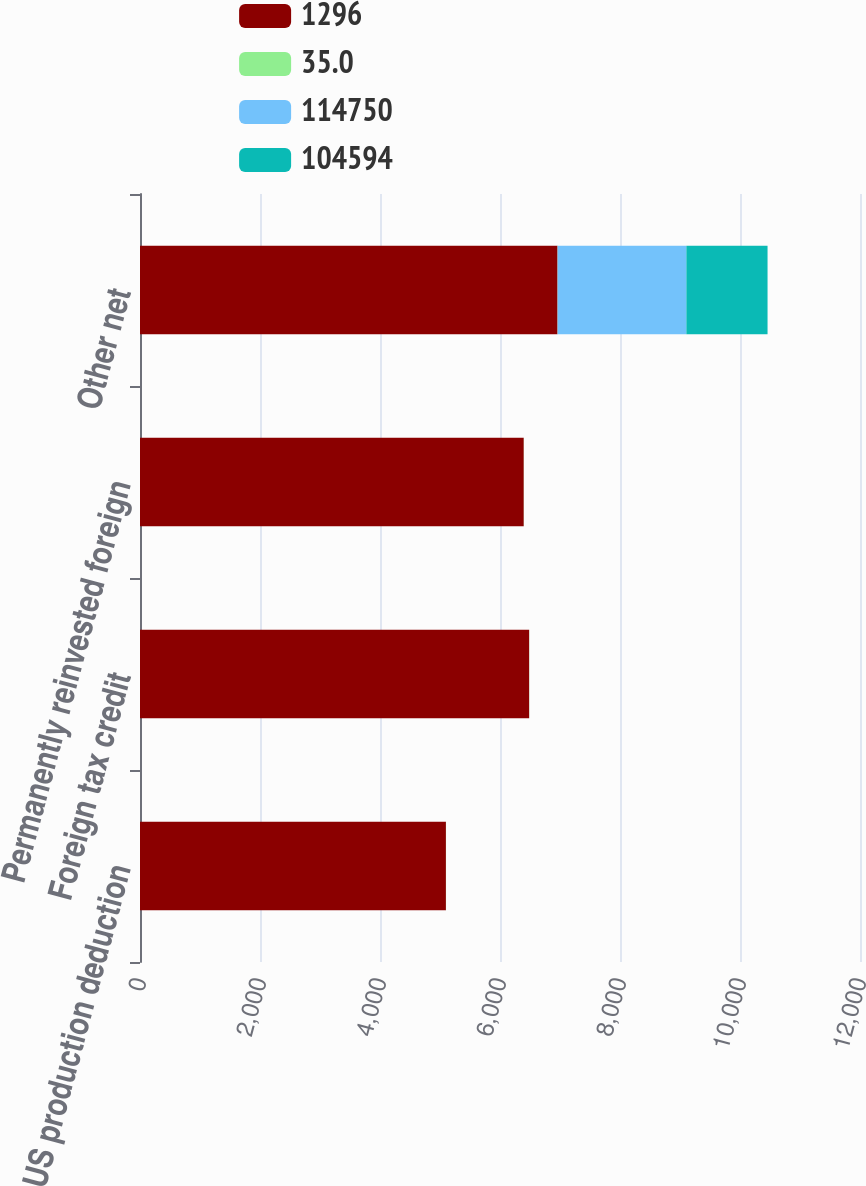Convert chart to OTSL. <chart><loc_0><loc_0><loc_500><loc_500><stacked_bar_chart><ecel><fcel>US production deduction<fcel>Foreign tax credit<fcel>Permanently reinvested foreign<fcel>Other net<nl><fcel>1296<fcel>5099<fcel>6486<fcel>6396<fcel>6959<nl><fcel>35<fcel>1.6<fcel>2<fcel>2<fcel>2.2<nl><fcel>114750<fcel>0<fcel>0<fcel>0<fcel>2145<nl><fcel>104594<fcel>0<fcel>0<fcel>0<fcel>1353<nl></chart> 